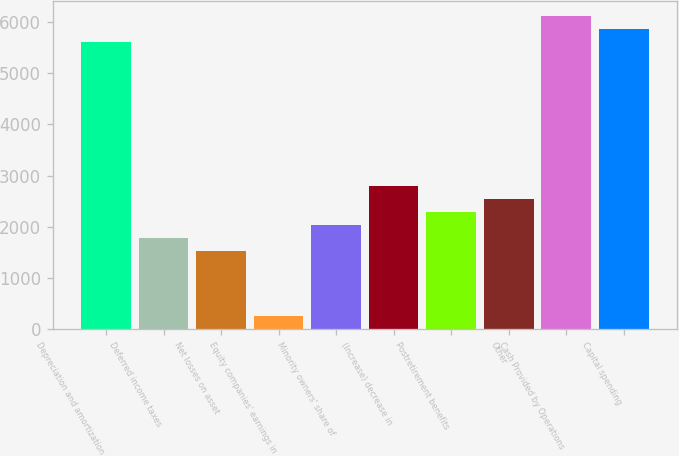Convert chart to OTSL. <chart><loc_0><loc_0><loc_500><loc_500><bar_chart><fcel>Depreciation and amortization<fcel>Deferred income taxes<fcel>Net losses on asset<fcel>Equity companies' earnings in<fcel>Minority owners' share of<fcel>(Increase) decrease in<fcel>Postretirement benefits<fcel>Other<fcel>Cash Provided by Operations<fcel>Capital spending<nl><fcel>5605.72<fcel>1788.82<fcel>1534.36<fcel>262.06<fcel>2043.28<fcel>2806.66<fcel>2297.74<fcel>2552.2<fcel>6114.64<fcel>5860.18<nl></chart> 